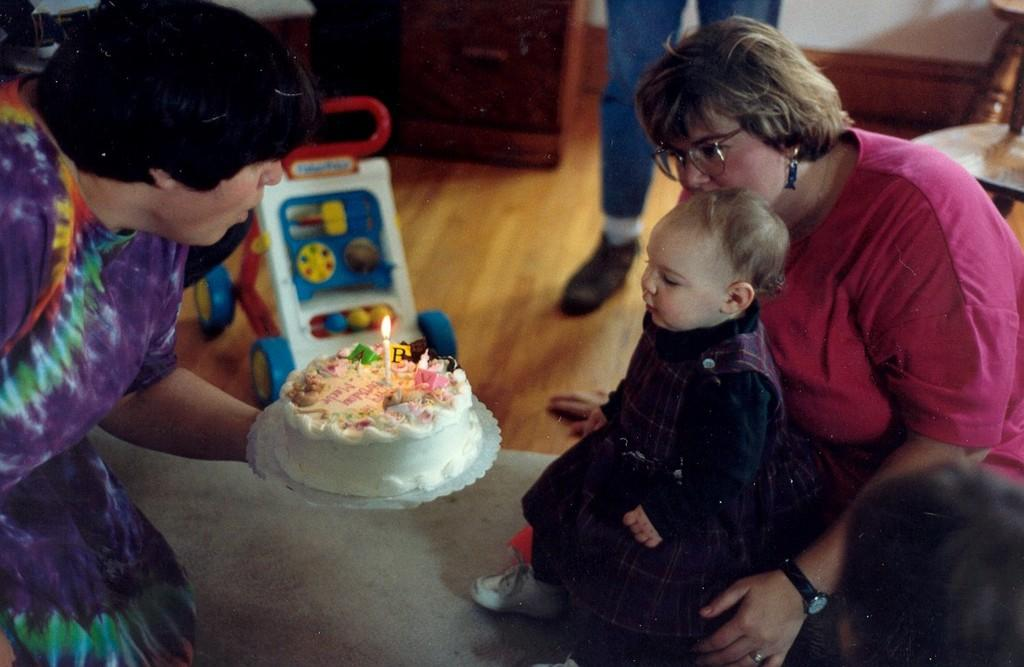What is the main object in the image? There is a cake in the image. What is placed on top of the cake? There is a candle in the image. What other objects can be seen in the image? There is a toy, a spectacle, and a watch in the image. Are there any objects on the floor in the image? Yes, there are objects on the floor in the image. Are there people on the floor in the image? Yes, there are people on the floor in the image. What can be seen in the background of the image? There is a wall visible in the background of the image. How many apples are being exchanged between the people on the floor in the image? There are no apples present in the image, and therefore no exchange of apples can be observed. 